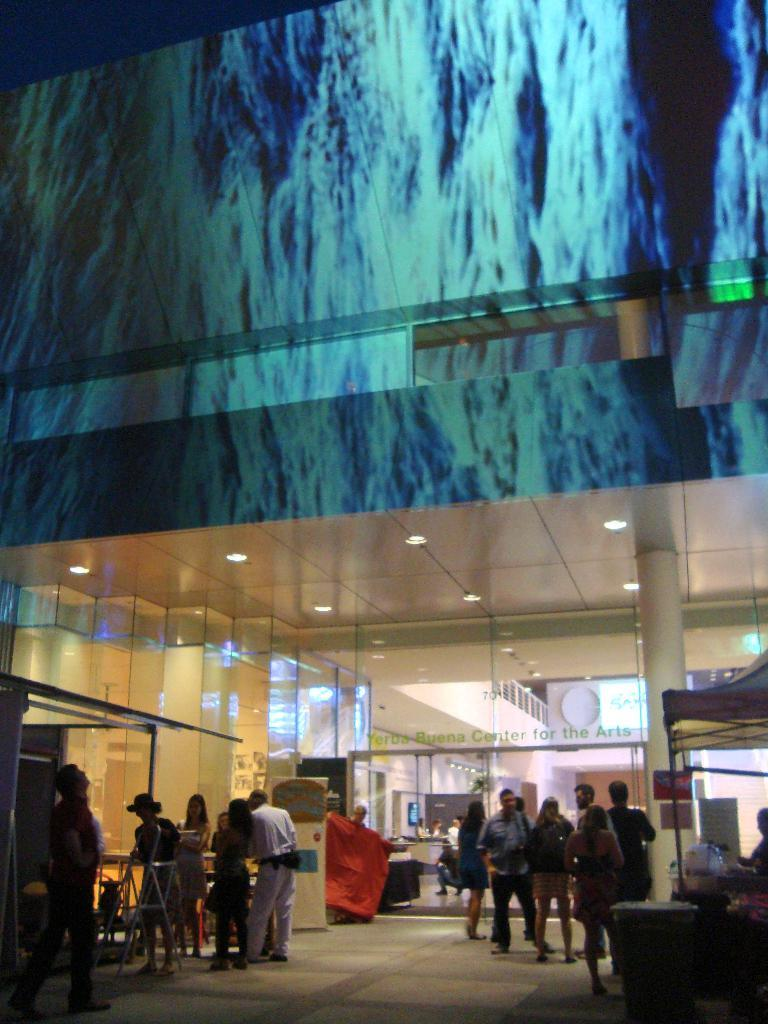What type of structure is visible in the image? There is a building in the image. Can you describe the people in the image? There are people standing outside the building. What additional features can be seen in the image? There are tents and a pillar in the image. Are there any other objects present in the image? Yes, there are other objects in the image. What is the noise level like in the image? There is no information about the noise level in the image, as it is a visual medium. 